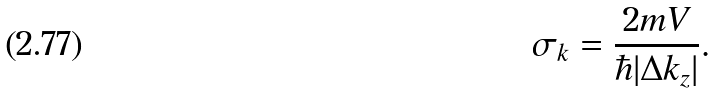<formula> <loc_0><loc_0><loc_500><loc_500>\sigma _ { k } = \frac { 2 m V } { \hbar { | } \Delta k _ { z } | } .</formula> 